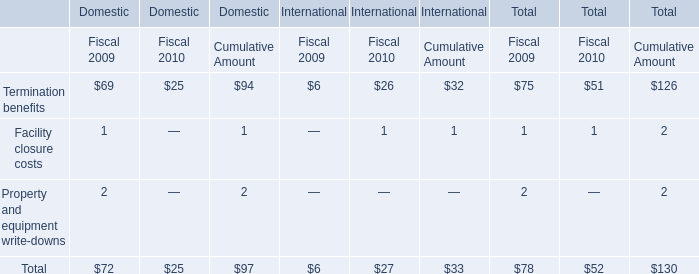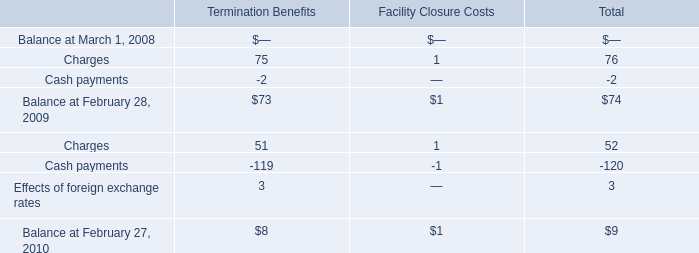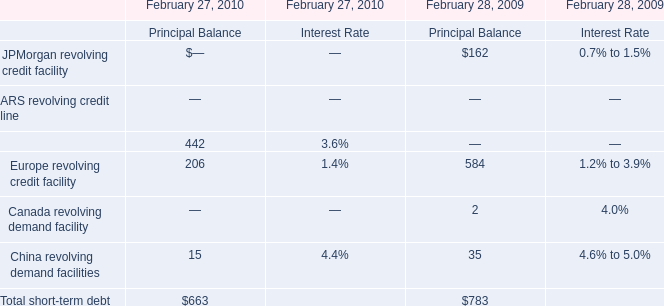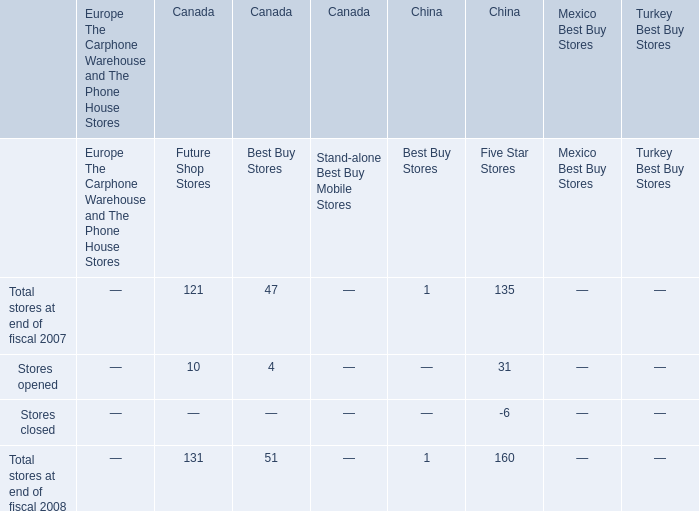What's the amount for the Cash payments for Termination Benefits in the year where Charges for Termination Benefits is higher? 
Answer: -2.0. 